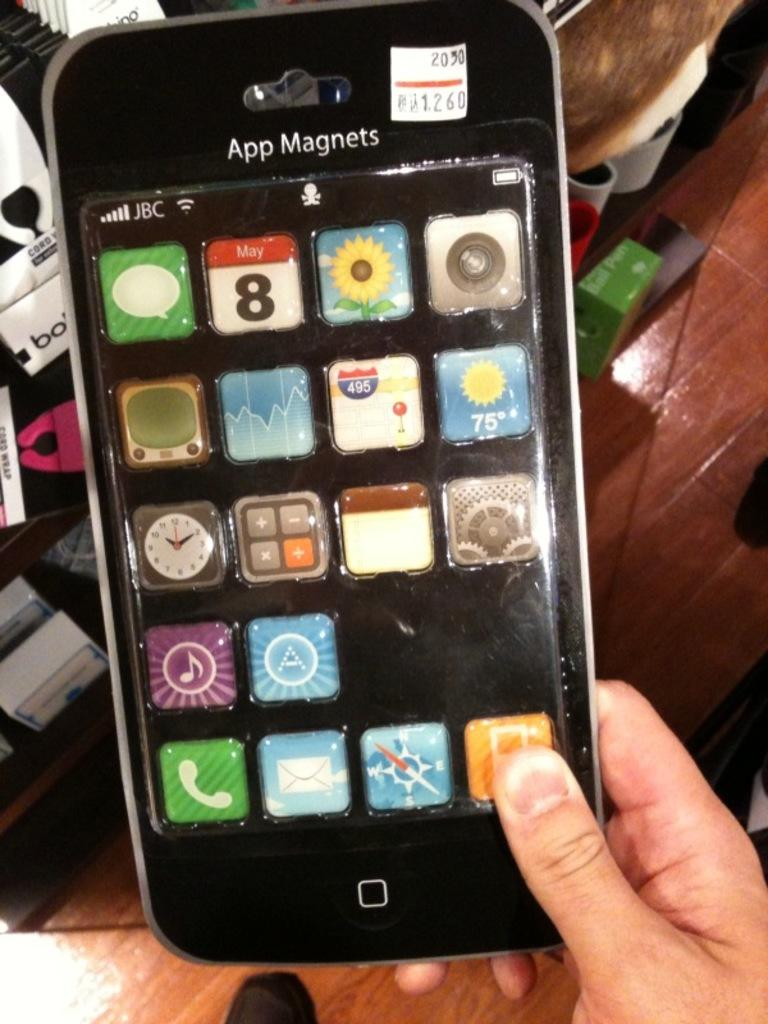<image>
Share a concise interpretation of the image provided. A customer in a store examines a set of app magnets. 